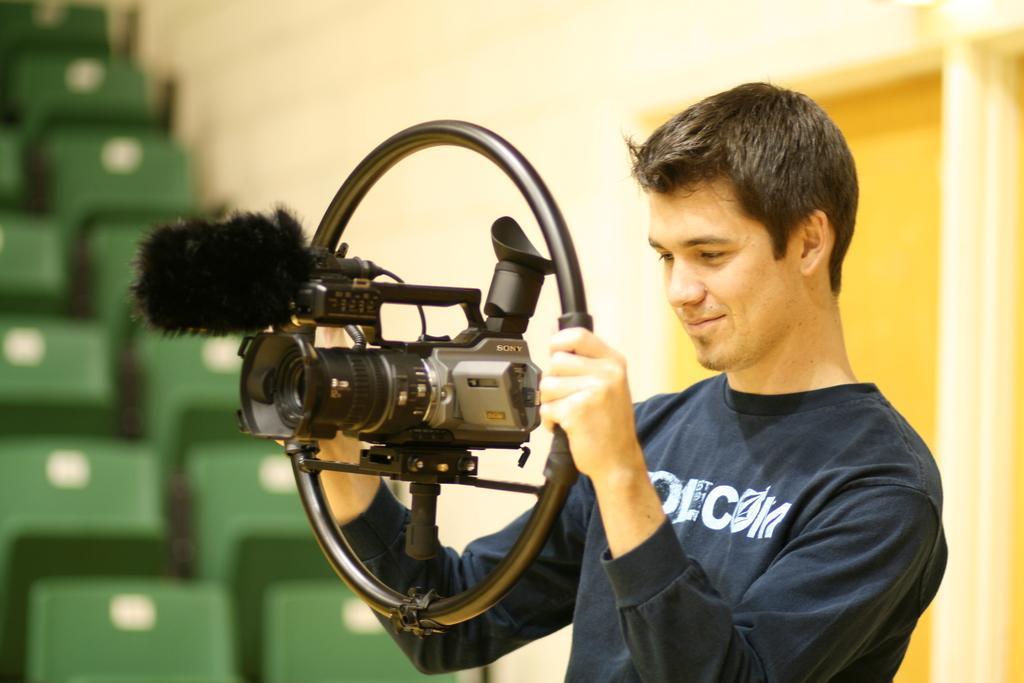Describe this image in one or two sentences. In the center of the image we can see a person holding a camera. In the background there are chairs and wall. 